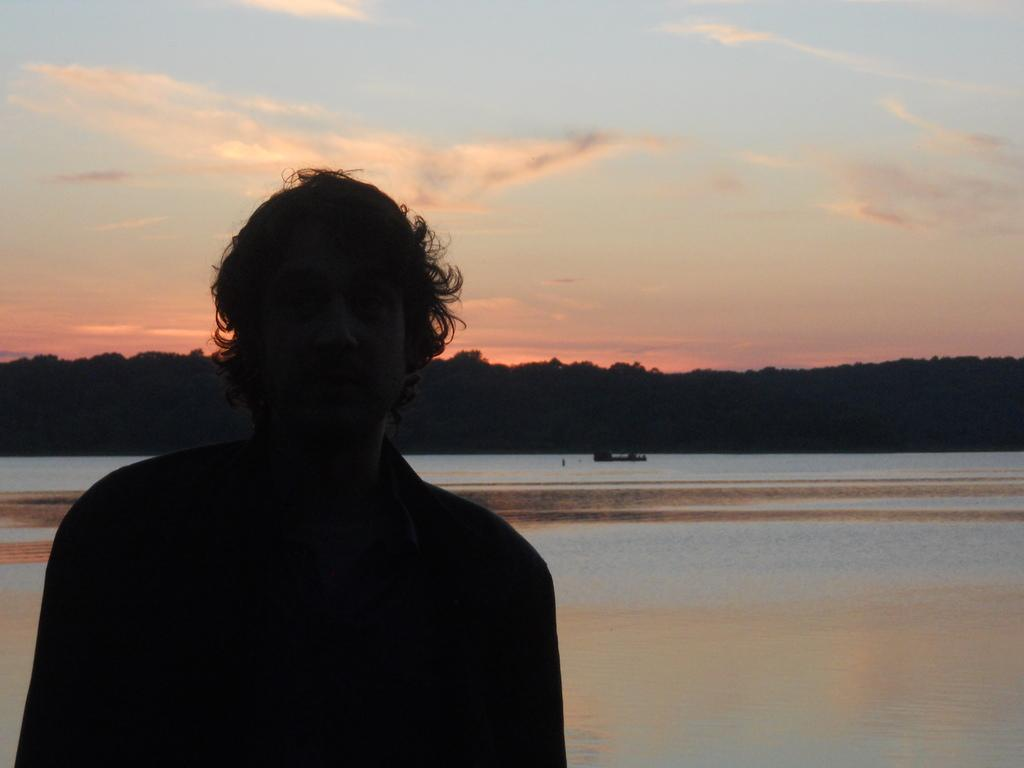Who is the main subject in the image? There is a man in the middle of the image. What can be seen in the background of the image? Water and trees are visible in the background of the image. What is visible at the top of the image? The sky is visible at the top of the image. What is the title of the book the man is reading in the image? There is no book or title visible in the image; the man is not holding or reading anything. 